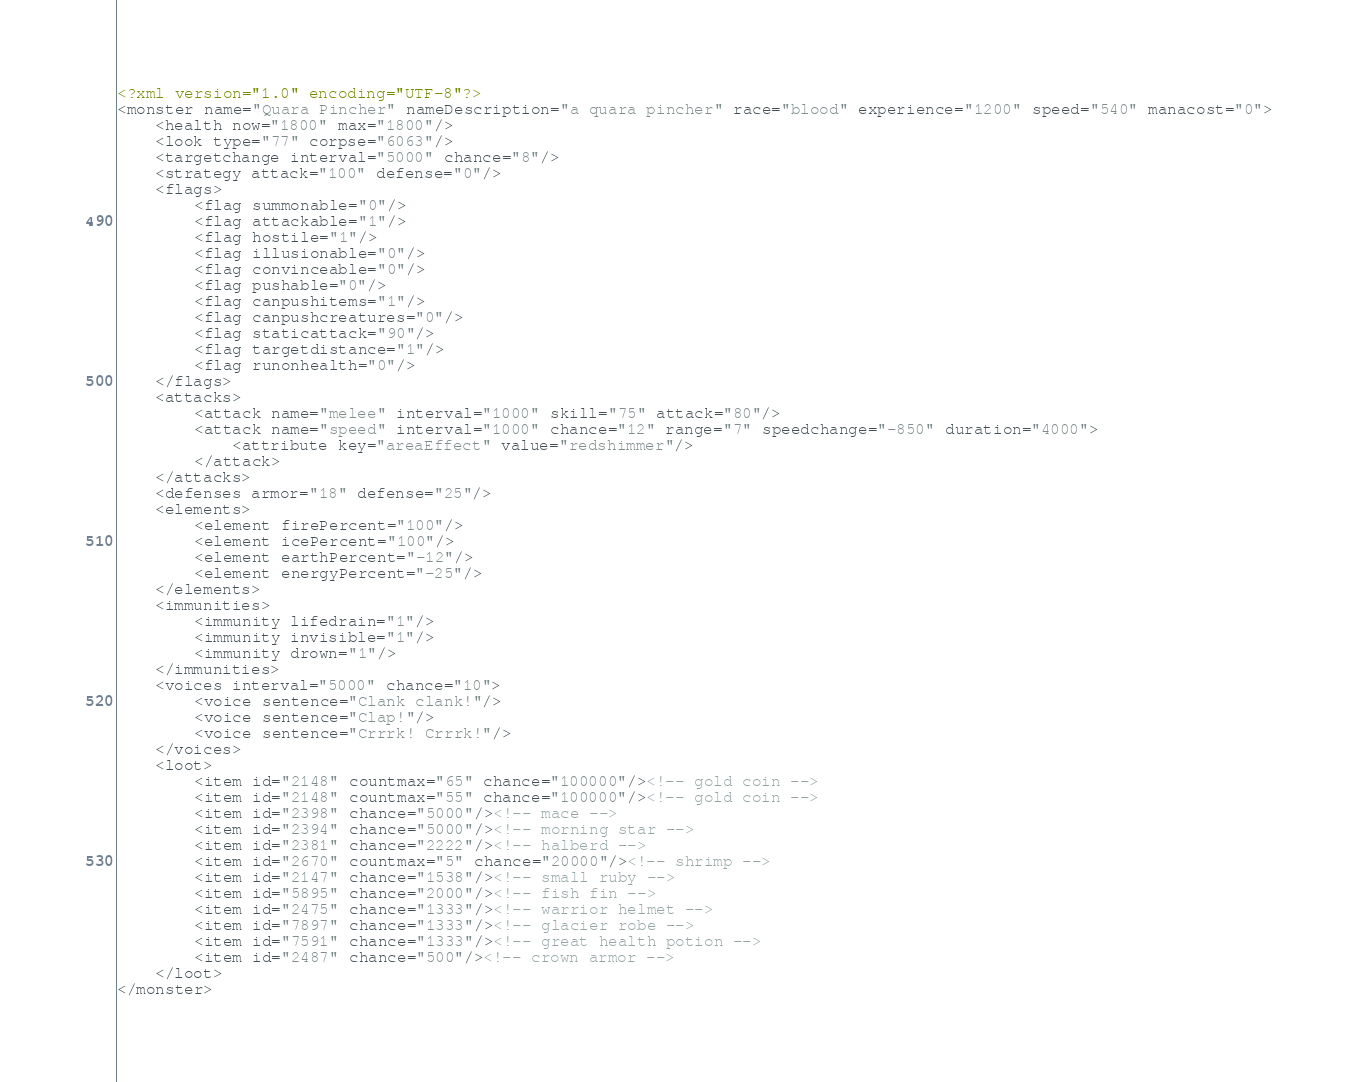Convert code to text. <code><loc_0><loc_0><loc_500><loc_500><_XML_><?xml version="1.0" encoding="UTF-8"?>
<monster name="Quara Pincher" nameDescription="a quara pincher" race="blood" experience="1200" speed="540" manacost="0">
	<health now="1800" max="1800"/>
	<look type="77" corpse="6063"/>
	<targetchange interval="5000" chance="8"/>
	<strategy attack="100" defense="0"/>
	<flags>
		<flag summonable="0"/>
		<flag attackable="1"/>
		<flag hostile="1"/>
		<flag illusionable="0"/>
		<flag convinceable="0"/>
		<flag pushable="0"/>
		<flag canpushitems="1"/>
		<flag canpushcreatures="0"/>
		<flag staticattack="90"/>
		<flag targetdistance="1"/>
		<flag runonhealth="0"/>
	</flags>
	<attacks>
		<attack name="melee" interval="1000" skill="75" attack="80"/>
		<attack name="speed" interval="1000" chance="12" range="7" speedchange="-850" duration="4000">
			<attribute key="areaEffect" value="redshimmer"/>
		</attack>
	</attacks>
	<defenses armor="18" defense="25"/>
	<elements>
		<element firePercent="100"/>
		<element icePercent="100"/>
		<element earthPercent="-12"/>
		<element energyPercent="-25"/>
	</elements>
	<immunities>
		<immunity lifedrain="1"/>
		<immunity invisible="1"/>
		<immunity drown="1"/>
	</immunities>
	<voices interval="5000" chance="10">
		<voice sentence="Clank clank!"/>
		<voice sentence="Clap!"/>
		<voice sentence="Crrrk! Crrrk!"/>
	</voices>
	<loot>
		<item id="2148" countmax="65" chance="100000"/><!-- gold coin -->
		<item id="2148" countmax="55" chance="100000"/><!-- gold coin -->
		<item id="2398" chance="5000"/><!-- mace -->
		<item id="2394" chance="5000"/><!-- morning star -->
		<item id="2381" chance="2222"/><!-- halberd -->
		<item id="2670" countmax="5" chance="20000"/><!-- shrimp -->
		<item id="2147" chance="1538"/><!-- small ruby -->
		<item id="5895" chance="2000"/><!-- fish fin -->
		<item id="2475" chance="1333"/><!-- warrior helmet -->
		<item id="7897" chance="1333"/><!-- glacier robe -->
		<item id="7591" chance="1333"/><!-- great health potion -->
		<item id="2487" chance="500"/><!-- crown armor -->
	</loot>
</monster>
</code> 